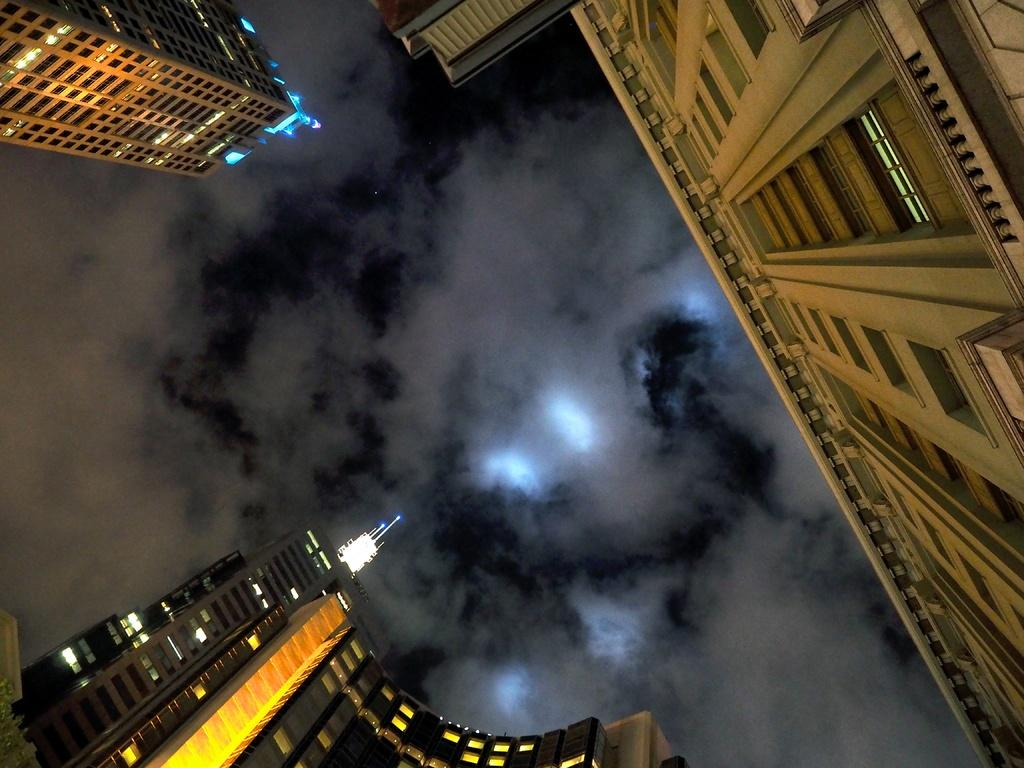What type of structures can be seen in the image? There are buildings in the image. What else can be seen in the image besides the buildings? There are lights visible in the image. What is visible in the background of the image? The sky is visible in the image, and clouds are present in the sky. How many frogs are controlling the lights in the image? There are no frogs present in the image, and therefore no such control can be observed. 